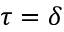Convert formula to latex. <formula><loc_0><loc_0><loc_500><loc_500>\tau = \delta</formula> 